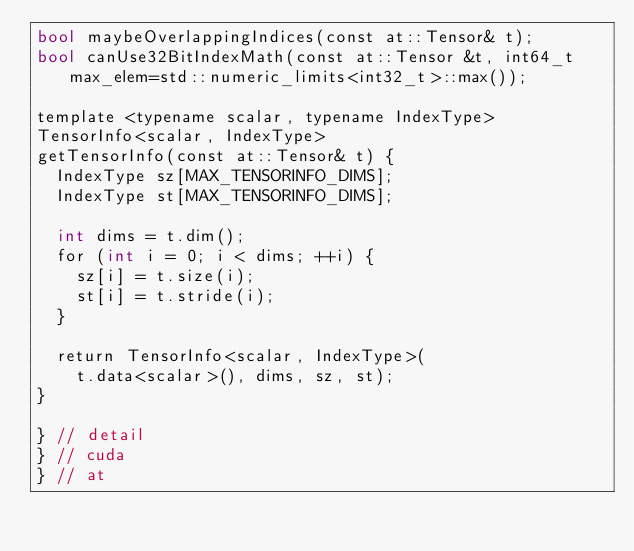<code> <loc_0><loc_0><loc_500><loc_500><_Cuda_>bool maybeOverlappingIndices(const at::Tensor& t);
bool canUse32BitIndexMath(const at::Tensor &t, int64_t max_elem=std::numeric_limits<int32_t>::max());

template <typename scalar, typename IndexType>
TensorInfo<scalar, IndexType>
getTensorInfo(const at::Tensor& t) {
  IndexType sz[MAX_TENSORINFO_DIMS];
  IndexType st[MAX_TENSORINFO_DIMS];

  int dims = t.dim();
  for (int i = 0; i < dims; ++i) {
    sz[i] = t.size(i);
    st[i] = t.stride(i);
  }

  return TensorInfo<scalar, IndexType>(
    t.data<scalar>(), dims, sz, st);
}

} // detail
} // cuda
} // at
</code> 